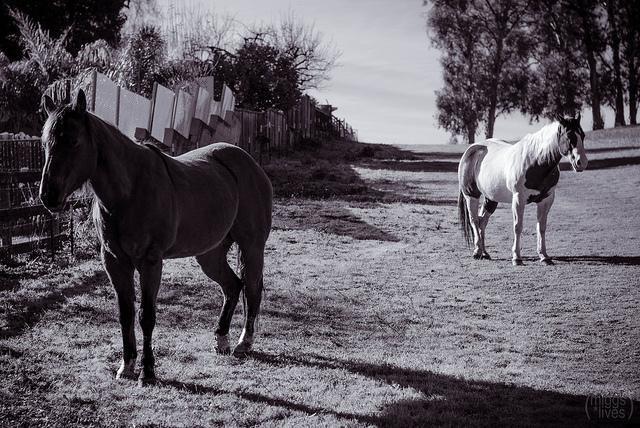How many horses are walking on the road?
Give a very brief answer. 2. How many horses are visible?
Give a very brief answer. 2. How many airplanes can you see?
Give a very brief answer. 0. 